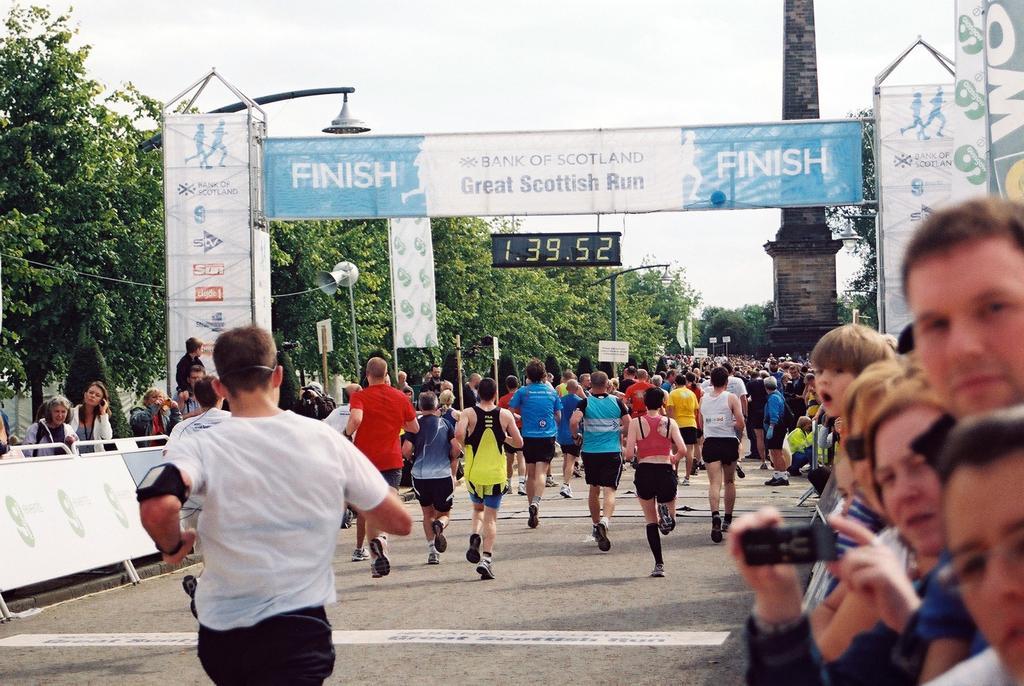How would you summarize this image in a sentence or two? In this image there are group of people running, there are barriers, there are group of people standing, boards to the poles, there are lights, poles, arch, trees, a megaphone, a digital clock, and in the background there is sky. 